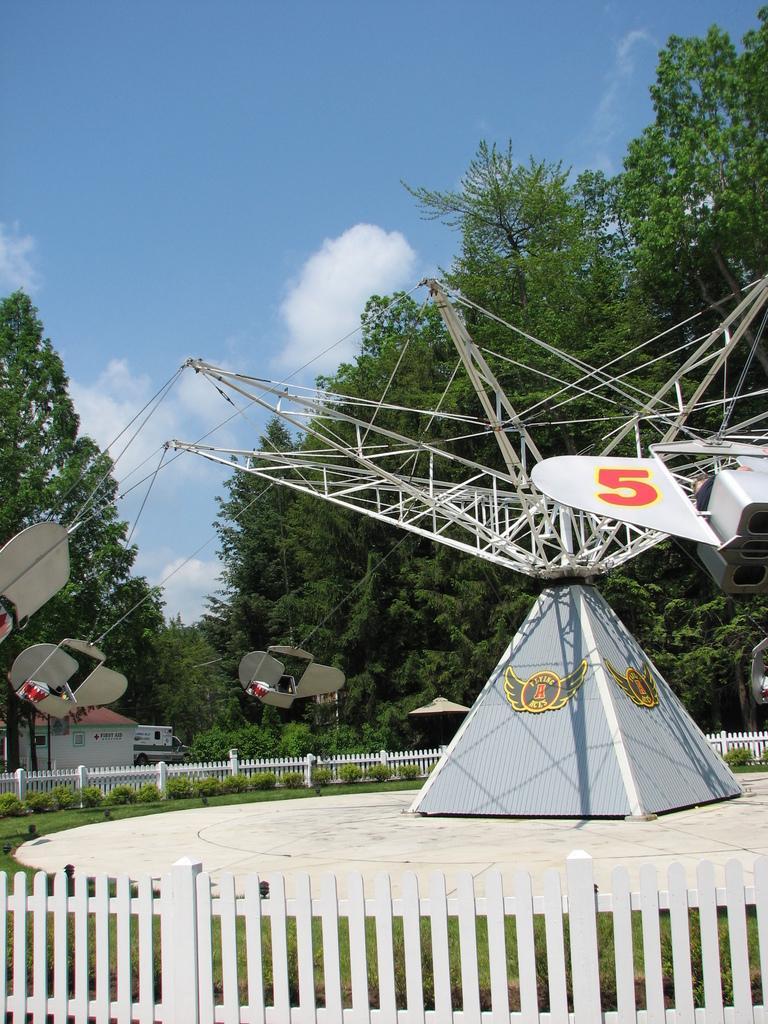Describe this image in one or two sentences. There is a white color fence. Besides this fence, there are plants and grass on the ground. Beside this grass, there is a circular platform , on which there is an object. In the background, there are trees, plants and a building on the ground and there are clouds in the blue sky. 